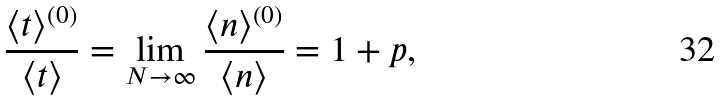<formula> <loc_0><loc_0><loc_500><loc_500>\frac { \langle t \rangle ^ { ( 0 ) } } { \langle t \rangle } = \lim _ { N \to \infty } \frac { \langle n \rangle ^ { ( 0 ) } } { \langle n \rangle } = 1 + p ,</formula> 